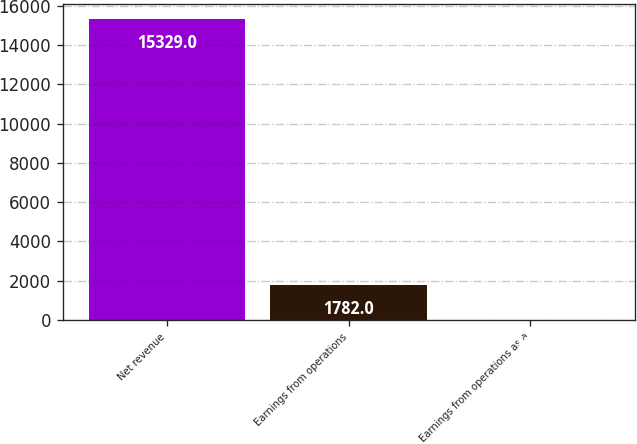Convert chart to OTSL. <chart><loc_0><loc_0><loc_500><loc_500><bar_chart><fcel>Net revenue<fcel>Earnings from operations<fcel>Earnings from operations as a<nl><fcel>15329<fcel>1782<fcel>11.6<nl></chart> 